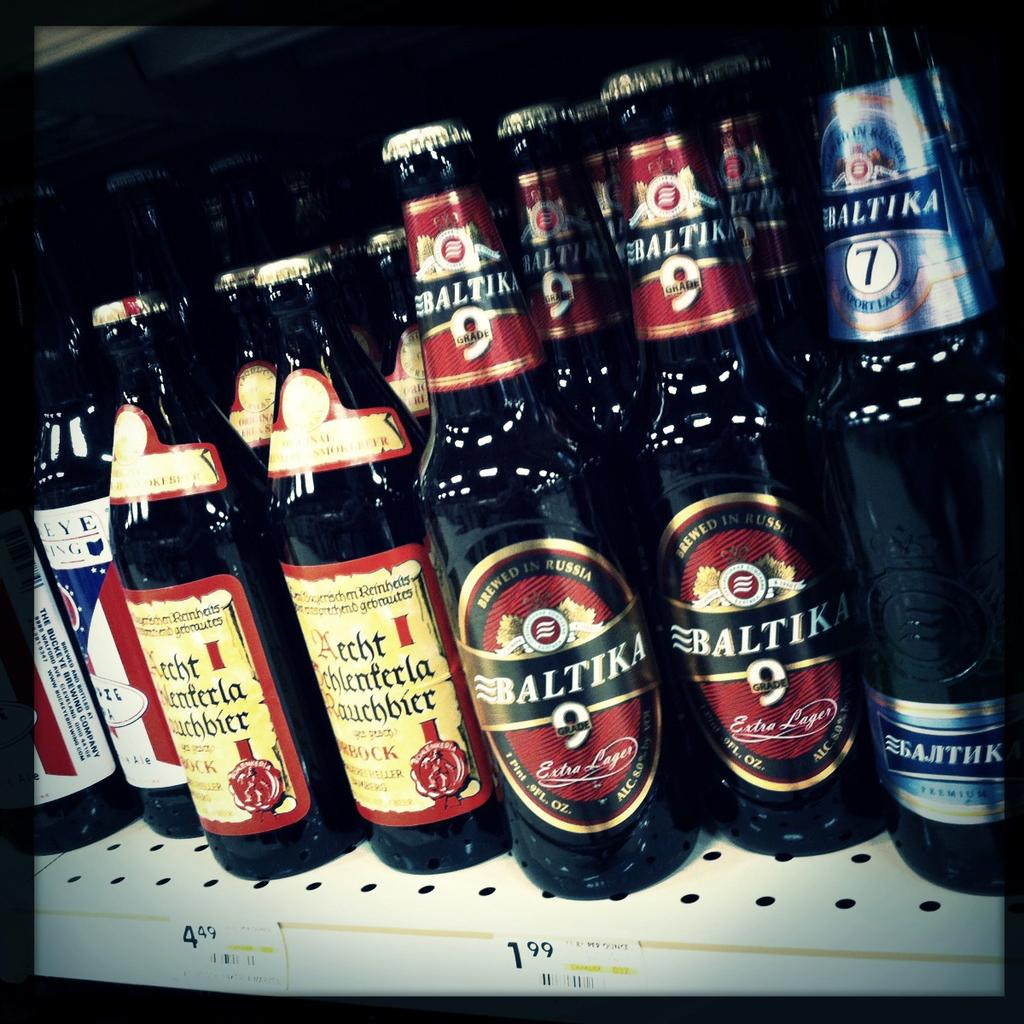<image>
Create a compact narrative representing the image presented. Two different types of Baltika brand beer are on the shelf. 